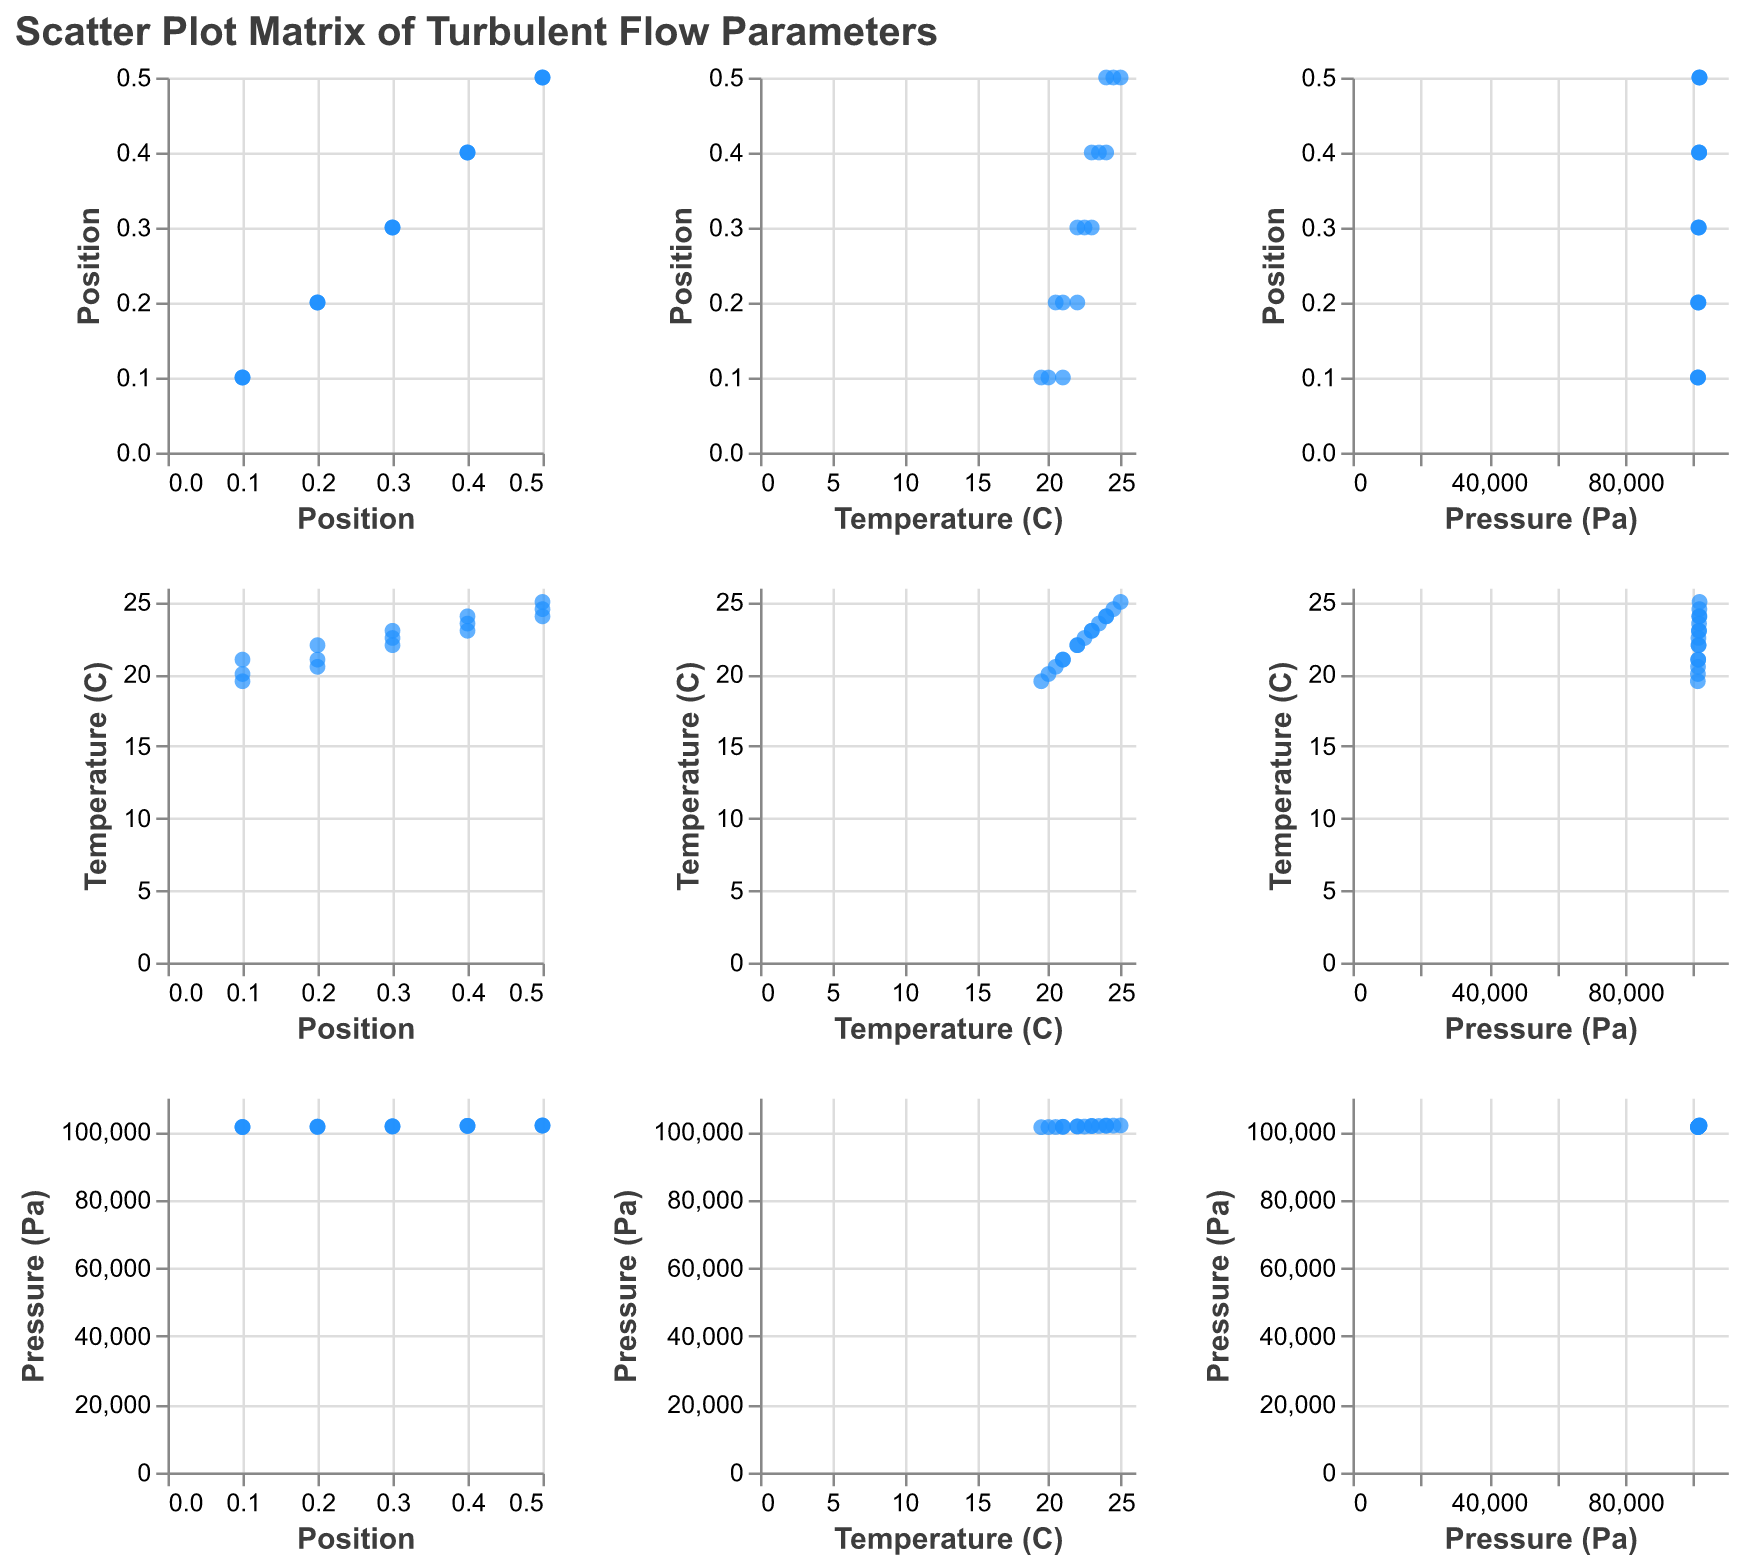What's the main color used for the data points in the scatter plots? All the data points in the scatter plots have a blue color, which helps make them stand out against the white background.
Answer: Blue What is the title of the Scatter Plot Matrix? The title of the Scatter Plot Matrix is visible at the top and it reads "Scatter Plot Matrix of Turbulent Flow Parameters".
Answer: Scatter Plot Matrix of Turbulent Flow Parameters How many data points are there in the plot? Counting all the dots present in the scatter plot matrix, we have a total of 15 data points.
Answer: 15 What is the trend of temperature at position 0.5? The temperature at position 0.5 shows an increasing trend in the scatter plot matrix, with the temperatures recorded being 24, 24.5, and 25 degrees Celsius respectively.
Answer: Increasing How does pressure change with position for all measurements? Observing the scatter plots, pressure generally increases with position from 0.1 to 0.5. Each position has a visibly higher average pressure value compared to the previous one.
Answer: Increases Is there a correlation between temperature and pressure? From the scatter plots showing Temperature (C) versus Pressure (Pa), it appears that higher temperatures correspond to slightly higher pressures, indicating a positive correlation.
Answer: Positive correlation Which position has the highest temperature recorded? Checking the scatter plot for Position vs. Temperature, the highest temperature recorded is 25 degrees Celsius, which occurs at position 0.5.
Answer: Position 0.5 What's the average pressure at position 0.3? The pressures at position 0.3 are 101600, 101480, and 101520 Pa. Calculating the average: (101600 + 101480 + 101520) / 3 gives 101533.33 Pa.
Answer: 101533.33 Pa Do temperature fluctuations appear more significant at lower or higher positions? Examining the scatter plots, temperature variations seem more significant at lower positions (0.1 and 0.2), with a wider spread of temperatures compared to higher positions.
Answer: Lower positions 